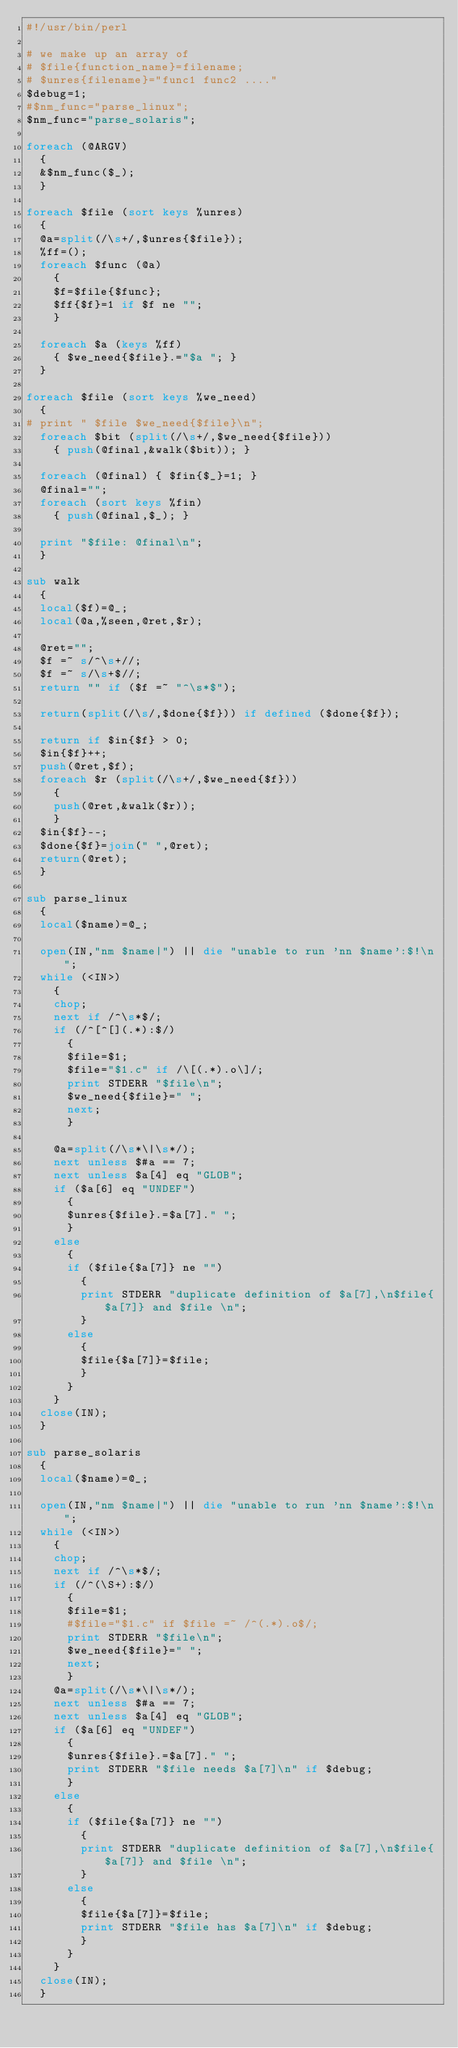<code> <loc_0><loc_0><loc_500><loc_500><_Perl_>#!/usr/bin/perl

# we make up an array of
# $file{function_name}=filename;
# $unres{filename}="func1 func2 ...."
$debug=1;
#$nm_func="parse_linux";
$nm_func="parse_solaris";

foreach (@ARGV)
	{
	&$nm_func($_);
	}

foreach $file (sort keys %unres)
	{
	@a=split(/\s+/,$unres{$file});
	%ff=();
	foreach $func (@a)
		{
		$f=$file{$func};
		$ff{$f}=1 if $f ne "";
		}

	foreach $a (keys %ff)
		{ $we_need{$file}.="$a "; }
	}

foreach $file (sort keys %we_need)
	{
#	print "	$file $we_need{$file}\n";
	foreach $bit (split(/\s+/,$we_need{$file}))
		{ push(@final,&walk($bit)); }

	foreach (@final) { $fin{$_}=1; }
	@final="";
	foreach (sort keys %fin)
		{ push(@final,$_); }

	print "$file: @final\n";
	}

sub walk
	{
	local($f)=@_;
	local(@a,%seen,@ret,$r);

	@ret="";
	$f =~ s/^\s+//;
	$f =~ s/\s+$//;
	return "" if ($f =~ "^\s*$");

	return(split(/\s/,$done{$f})) if defined ($done{$f});

	return if $in{$f} > 0;
	$in{$f}++;
	push(@ret,$f);
	foreach $r (split(/\s+/,$we_need{$f}))
		{
		push(@ret,&walk($r));
		}
	$in{$f}--;
	$done{$f}=join(" ",@ret);
	return(@ret);
	}

sub parse_linux
	{
	local($name)=@_;

	open(IN,"nm $name|") || die "unable to run 'nn $name':$!\n";
	while (<IN>)
		{
		chop;
		next if /^\s*$/;
		if (/^[^[](.*):$/)
			{
			$file=$1;
			$file="$1.c" if /\[(.*).o\]/;
			print STDERR "$file\n";
			$we_need{$file}=" ";
			next;
			}

		@a=split(/\s*\|\s*/);
		next unless $#a == 7;
		next unless $a[4] eq "GLOB";
		if ($a[6] eq "UNDEF")
			{
			$unres{$file}.=$a[7]." ";
			}
		else
			{
			if ($file{$a[7]} ne "")
				{
				print STDERR "duplicate definition of $a[7],\n$file{$a[7]} and $file \n";
				}
			else
				{
				$file{$a[7]}=$file;
				}
			}
		}
	close(IN);
	}

sub parse_solaris
	{
	local($name)=@_;

	open(IN,"nm $name|") || die "unable to run 'nn $name':$!\n";
	while (<IN>)
		{
		chop;
		next if /^\s*$/;
		if (/^(\S+):$/)
			{
			$file=$1;
			#$file="$1.c" if $file =~ /^(.*).o$/;
			print STDERR "$file\n";
			$we_need{$file}=" ";
			next;
			}
		@a=split(/\s*\|\s*/);
		next unless $#a == 7;
		next unless $a[4] eq "GLOB";
		if ($a[6] eq "UNDEF")
			{
			$unres{$file}.=$a[7]." ";
			print STDERR "$file needs $a[7]\n" if $debug;
			}
		else
			{
			if ($file{$a[7]} ne "")
				{
				print STDERR "duplicate definition of $a[7],\n$file{$a[7]} and $file \n";
				}
			else
				{
				$file{$a[7]}=$file;
				print STDERR "$file has $a[7]\n" if $debug;
				}
			}
		}
	close(IN);
	}

</code> 